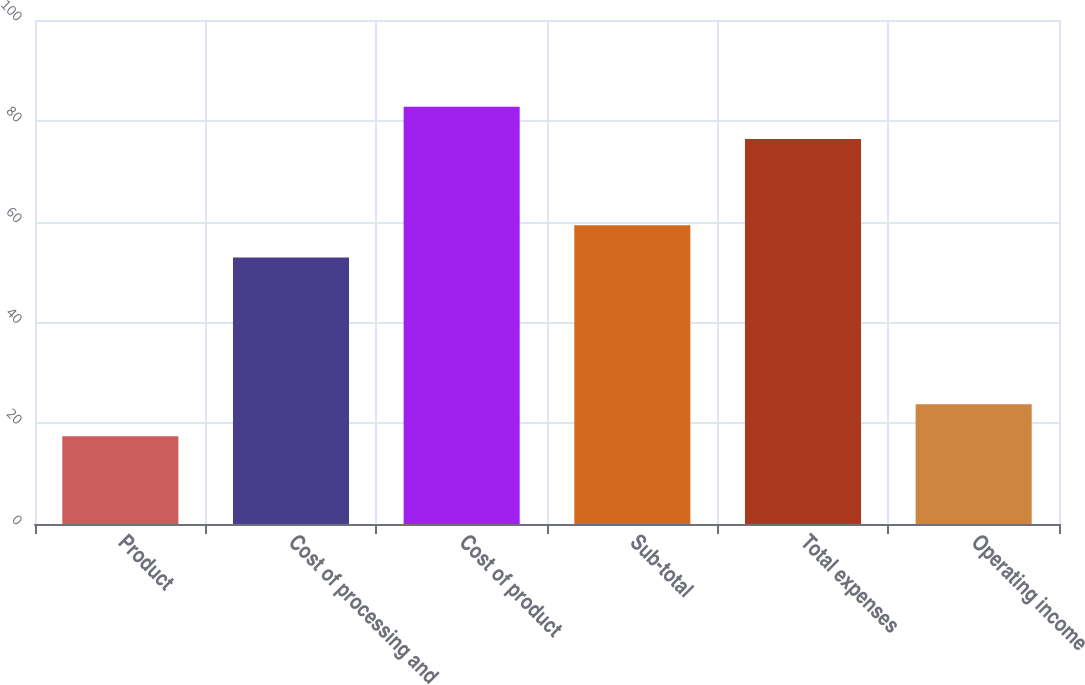<chart> <loc_0><loc_0><loc_500><loc_500><bar_chart><fcel>Product<fcel>Cost of processing and<fcel>Cost of product<fcel>Sub-total<fcel>Total expenses<fcel>Operating income<nl><fcel>17.4<fcel>52.9<fcel>82.78<fcel>59.28<fcel>76.4<fcel>23.78<nl></chart> 